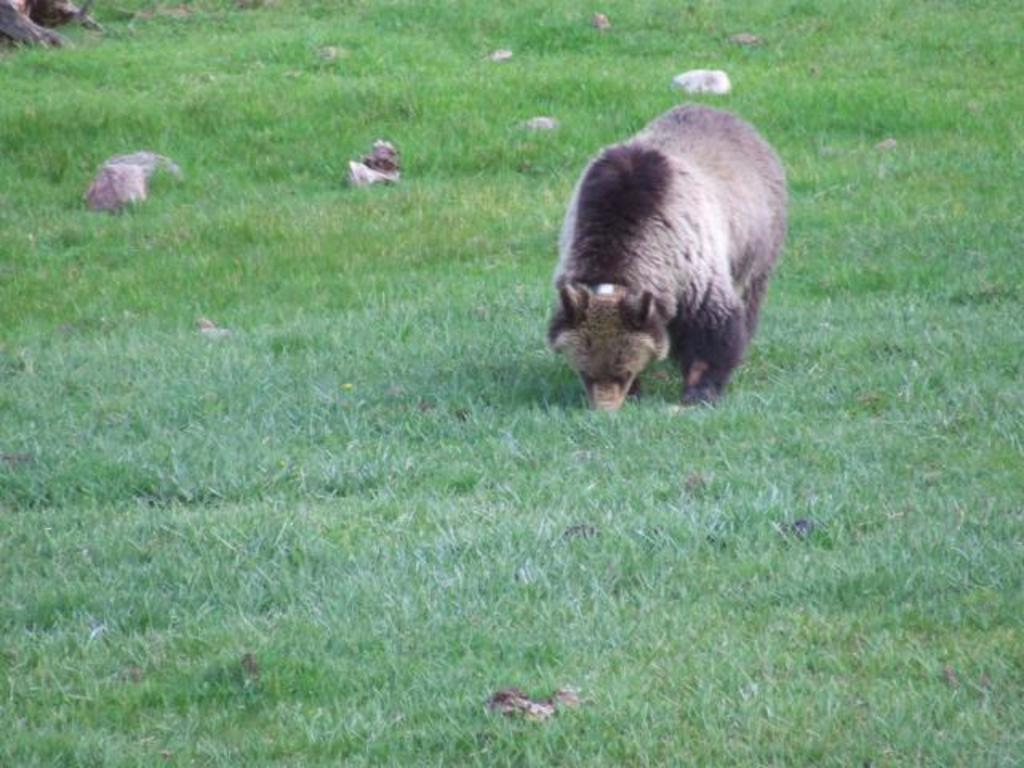What type of animal is in the image? There is an animal in the image, but the specific type cannot be determined from the provided facts. Where is the animal located in the image? The animal is on the grass in the image. What can be seen in the background of the image? There is an object and stones in the background of the image. How many tins are stacked on the crate in the image? There is no crate or tin present in the image. What type of flock is visible in the image? There is no flock visible in the image. 